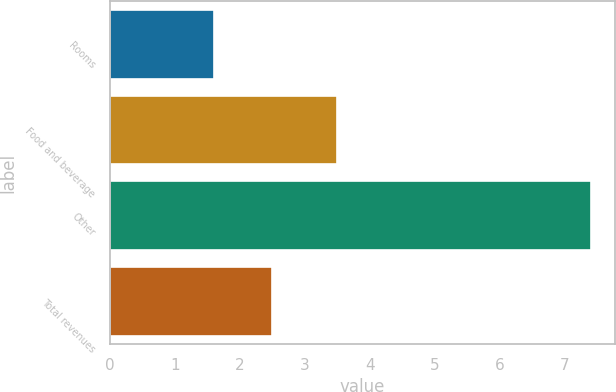Convert chart. <chart><loc_0><loc_0><loc_500><loc_500><bar_chart><fcel>Rooms<fcel>Food and beverage<fcel>Other<fcel>Total revenues<nl><fcel>1.6<fcel>3.5<fcel>7.4<fcel>2.5<nl></chart> 